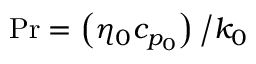<formula> <loc_0><loc_0><loc_500><loc_500>P r = \left ( { \eta _ { 0 } c _ { p _ { 0 } } } \right ) \Big / k _ { 0 }</formula> 